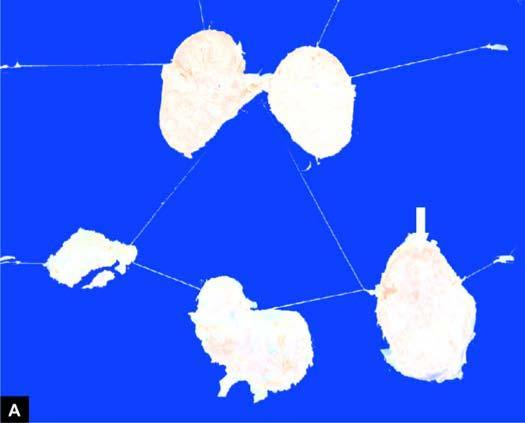does sectioned slice of the liver cut section of matted mass of lymph nodes show merging capsules and large areas of caseation necrosis?
Answer the question using a single word or phrase. No 